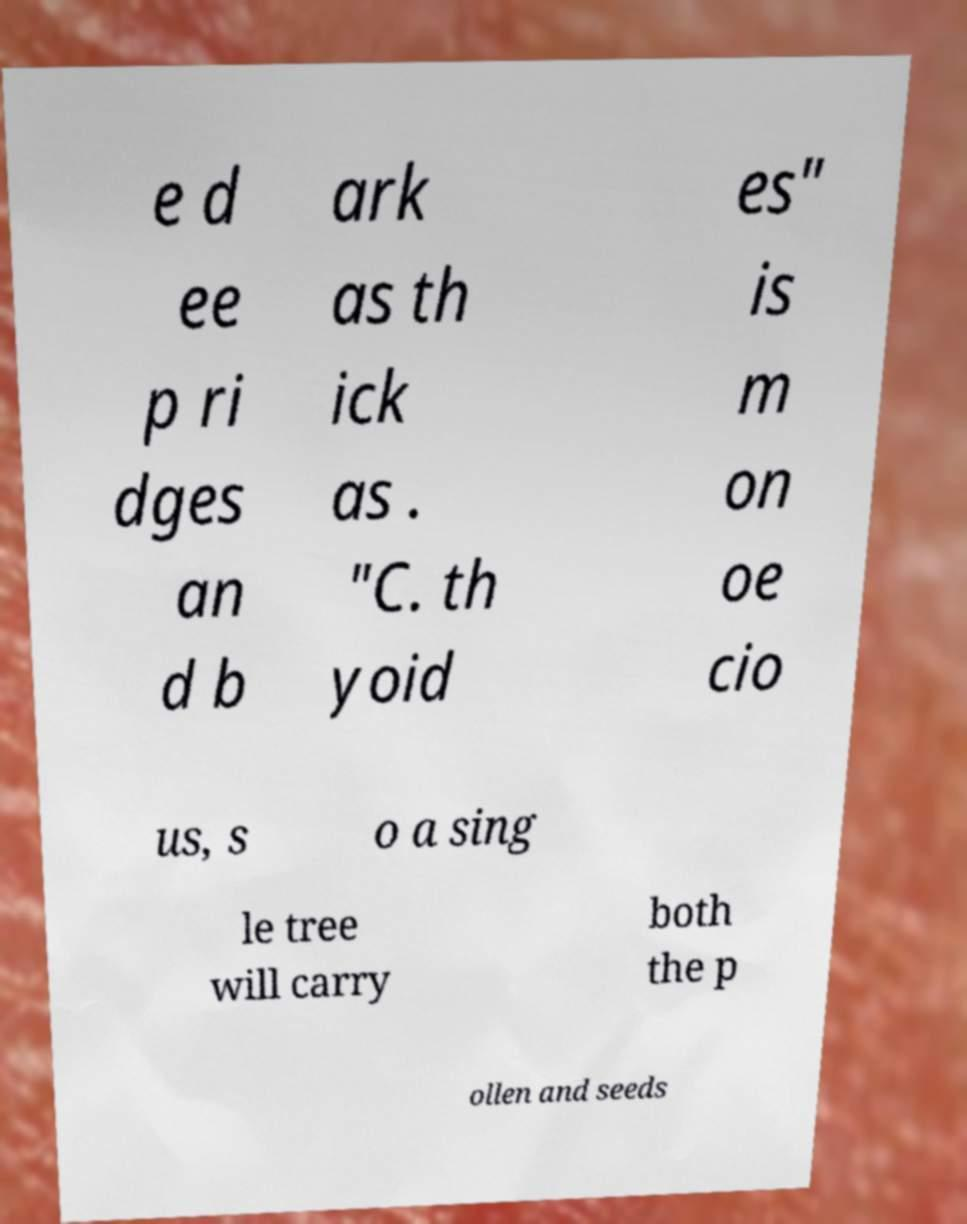Please read and relay the text visible in this image. What does it say? e d ee p ri dges an d b ark as th ick as . "C. th yoid es" is m on oe cio us, s o a sing le tree will carry both the p ollen and seeds 